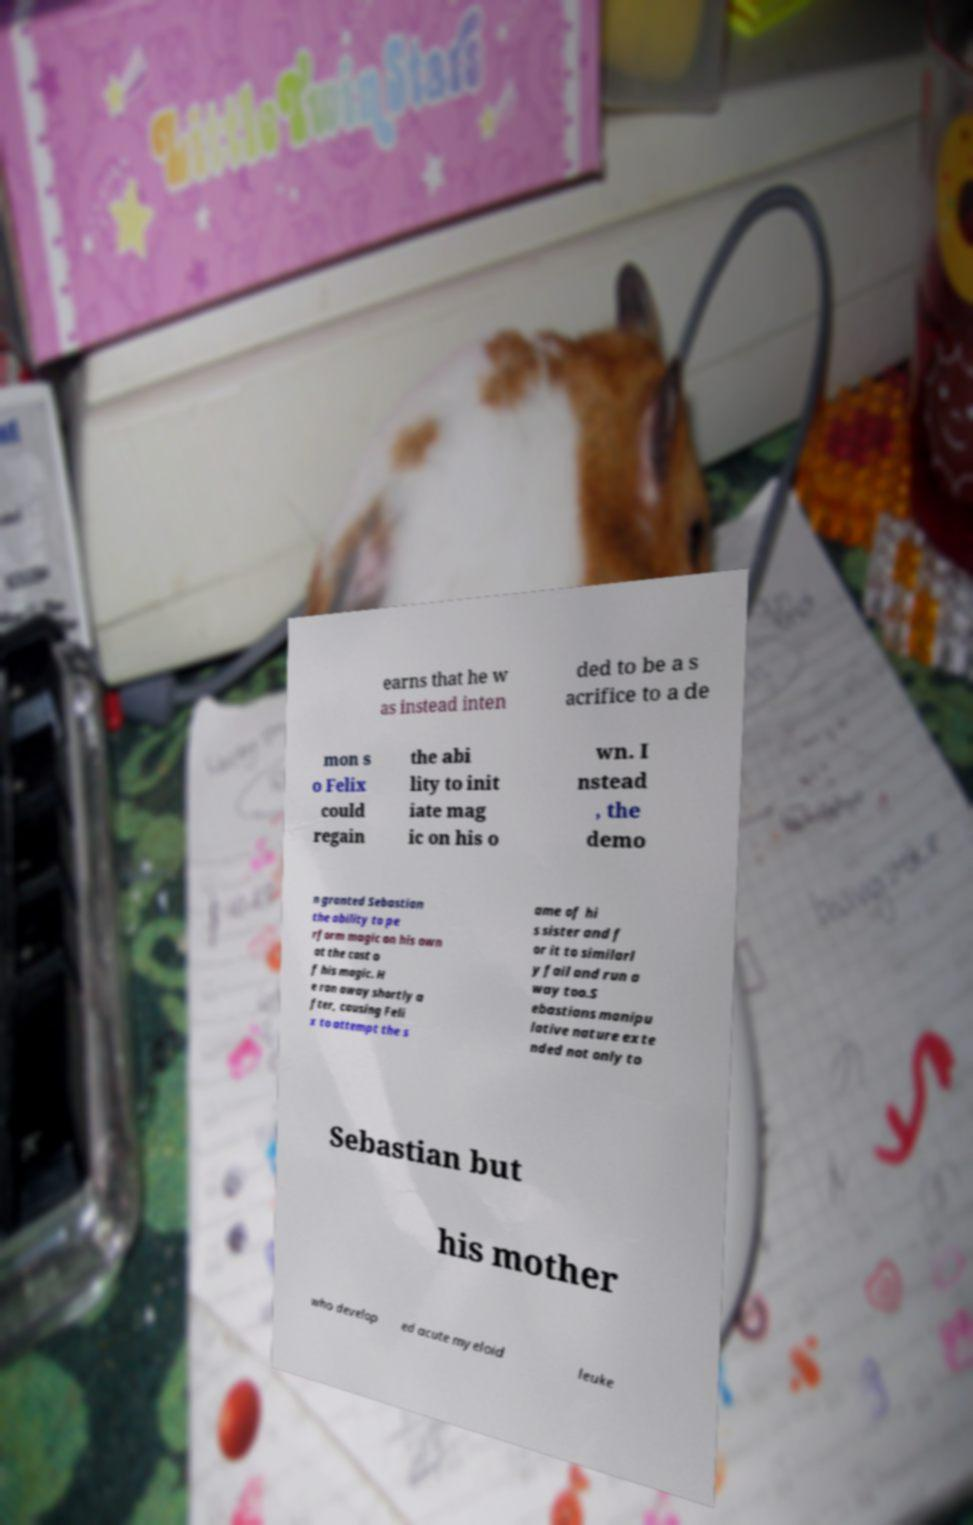What messages or text are displayed in this image? I need them in a readable, typed format. earns that he w as instead inten ded to be a s acrifice to a de mon s o Felix could regain the abi lity to init iate mag ic on his o wn. I nstead , the demo n granted Sebastian the ability to pe rform magic on his own at the cost o f his magic. H e ran away shortly a fter, causing Feli x to attempt the s ame of hi s sister and f or it to similarl y fail and run a way too.S ebastians manipu lative nature exte nded not only to Sebastian but his mother who develop ed acute myeloid leuke 